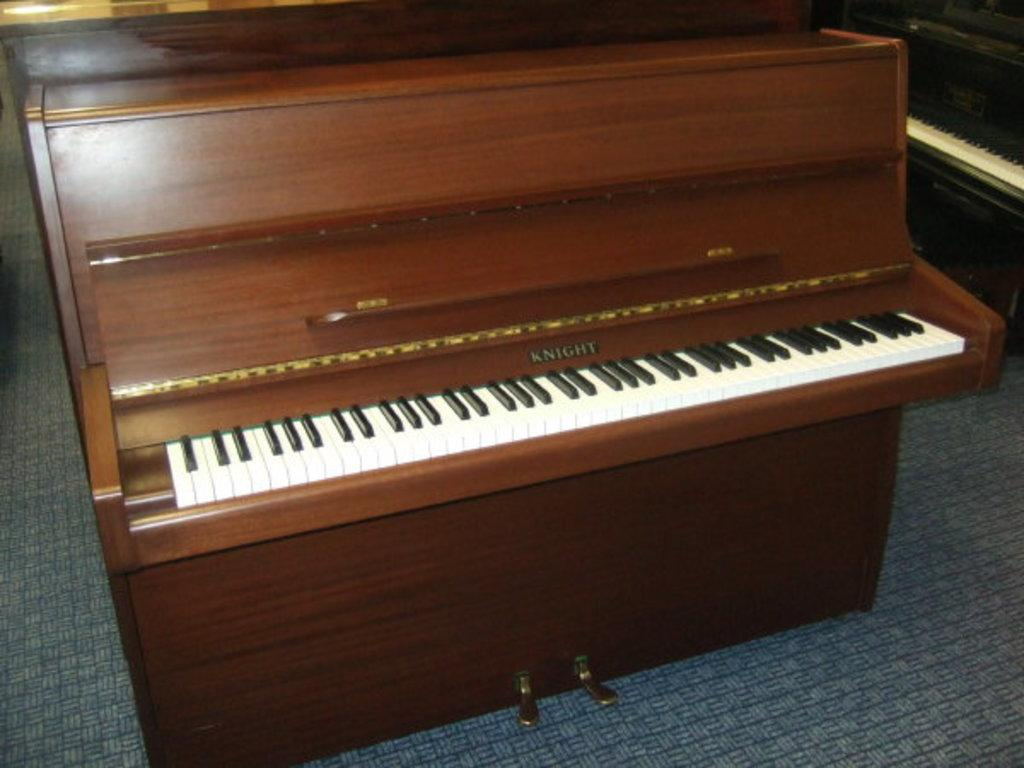What type of musical instrument is present in the image? There are two pianos in the image, a brown one and a black one. How are the pianos positioned in the image? The brown piano is placed on the floor, and the black piano is placed to the right side of the image. What type of jam is being served on the pianos in the image? There is no jam present in the image; it features two pianos, a brown one and a black one. Is there any smoke coming from the pianos in the image? No, there is no smoke coming from the pianos in the image. 